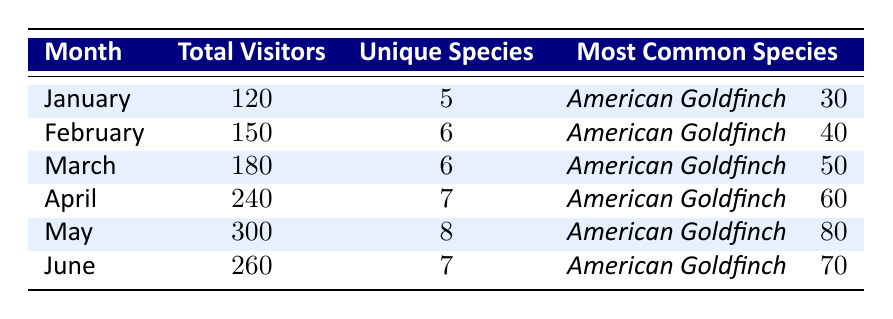What was the total number of visitors in May? The table shows that the total number of visitors in May is listed directly under the "Total Visitors" column for that month. The value next to May is 300.
Answer: 300 Which month had the highest unique species count? To find the month with the highest unique species count, we compare the "Unique Species" column across all months. May has the highest count of 8.
Answer: May How many total visitors were there in January and February combined? To find the combined visitors, we add the total visitors from January (120) and February (150). The sum is 120 + 150 = 270.
Answer: 270 What is the most common species in April, and how many were counted? The table shows that in April, the most common species is the American Goldfinch with a count of 60, listed under the "Most Common Species" for that month.
Answer: American Goldfinch, 60 Did more visitors come in March than in June? By comparing the total visitors, March has 180 visitors while June has 260. Since 180 is less than 260, the statement is false.
Answer: No How many more unique species were there in May compared to January? The unique species in May is 8, while in January it is 5. To find the difference, subtract January's unique species from May's: 8 - 5 = 3.
Answer: 3 What was the average number of total visitors for the months from January to June? To calculate the average, first sum the total visitors from each month: 120 + 150 + 180 + 240 + 300 + 260 = 1250. Then divide by the number of months (6): 1250 / 6 ≈ 208.33.
Answer: 208.33 Did the number of American Goldfinches increase every month? Checking the counts of American Goldfinches across the months, we see: 30 (Jan), 40 (Feb), 50 (Mar), 60 (Apr), 80 (May), 70 (Jun). The count decreased from May to June, so it did not increase every month.
Answer: No What percentage of total visitors in April were American Goldfinches? In April, there are 240 total visitors. The count of American Goldfinches is 60. To find the percentage: (60 / 240) * 100 = 25%.
Answer: 25% Which month had the least visitors, and how many were there? By looking at the "Total Visitors" column, January has the least with 120 visitors listed for that month.
Answer: January, 120 